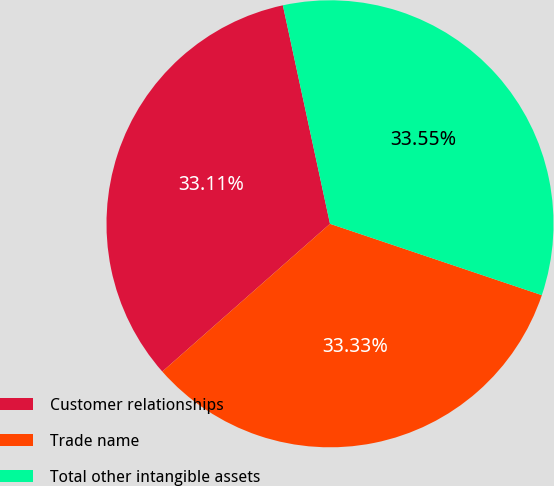<chart> <loc_0><loc_0><loc_500><loc_500><pie_chart><fcel>Customer relationships<fcel>Trade name<fcel>Total other intangible assets<nl><fcel>33.11%<fcel>33.33%<fcel>33.55%<nl></chart> 